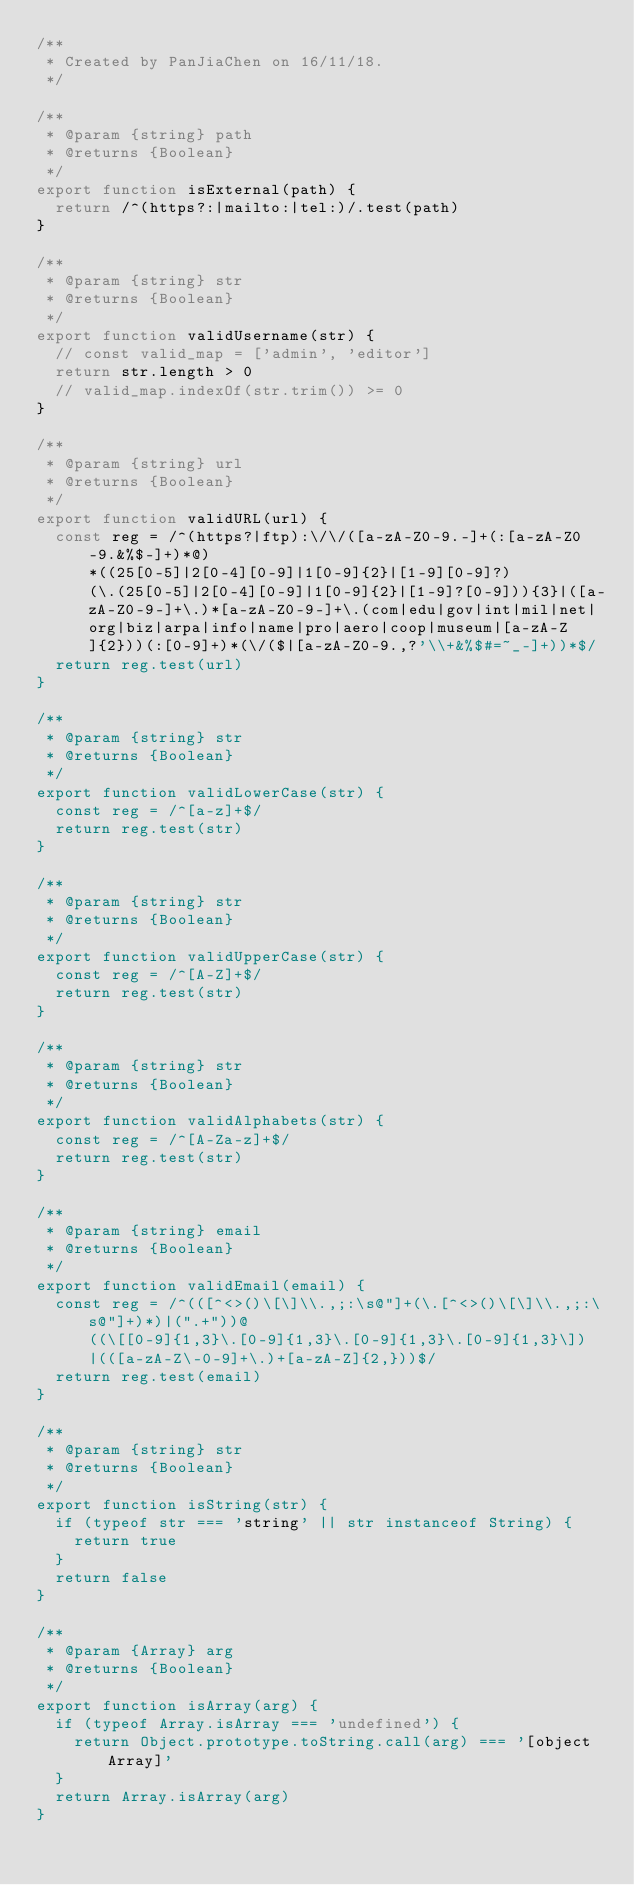<code> <loc_0><loc_0><loc_500><loc_500><_JavaScript_>/**
 * Created by PanJiaChen on 16/11/18.
 */

/**
 * @param {string} path
 * @returns {Boolean}
 */
export function isExternal(path) {
  return /^(https?:|mailto:|tel:)/.test(path)
}

/**
 * @param {string} str
 * @returns {Boolean}
 */
export function validUsername(str) {
  // const valid_map = ['admin', 'editor']
  return str.length > 0
  // valid_map.indexOf(str.trim()) >= 0
}

/**
 * @param {string} url
 * @returns {Boolean}
 */
export function validURL(url) {
  const reg = /^(https?|ftp):\/\/([a-zA-Z0-9.-]+(:[a-zA-Z0-9.&%$-]+)*@)*((25[0-5]|2[0-4][0-9]|1[0-9]{2}|[1-9][0-9]?)(\.(25[0-5]|2[0-4][0-9]|1[0-9]{2}|[1-9]?[0-9])){3}|([a-zA-Z0-9-]+\.)*[a-zA-Z0-9-]+\.(com|edu|gov|int|mil|net|org|biz|arpa|info|name|pro|aero|coop|museum|[a-zA-Z]{2}))(:[0-9]+)*(\/($|[a-zA-Z0-9.,?'\\+&%$#=~_-]+))*$/
  return reg.test(url)
}

/**
 * @param {string} str
 * @returns {Boolean}
 */
export function validLowerCase(str) {
  const reg = /^[a-z]+$/
  return reg.test(str)
}

/**
 * @param {string} str
 * @returns {Boolean}
 */
export function validUpperCase(str) {
  const reg = /^[A-Z]+$/
  return reg.test(str)
}

/**
 * @param {string} str
 * @returns {Boolean}
 */
export function validAlphabets(str) {
  const reg = /^[A-Za-z]+$/
  return reg.test(str)
}

/**
 * @param {string} email
 * @returns {Boolean}
 */
export function validEmail(email) {
  const reg = /^(([^<>()\[\]\\.,;:\s@"]+(\.[^<>()\[\]\\.,;:\s@"]+)*)|(".+"))@((\[[0-9]{1,3}\.[0-9]{1,3}\.[0-9]{1,3}\.[0-9]{1,3}\])|(([a-zA-Z\-0-9]+\.)+[a-zA-Z]{2,}))$/
  return reg.test(email)
}

/**
 * @param {string} str
 * @returns {Boolean}
 */
export function isString(str) {
  if (typeof str === 'string' || str instanceof String) {
    return true
  }
  return false
}

/**
 * @param {Array} arg
 * @returns {Boolean}
 */
export function isArray(arg) {
  if (typeof Array.isArray === 'undefined') {
    return Object.prototype.toString.call(arg) === '[object Array]'
  }
  return Array.isArray(arg)
}
</code> 